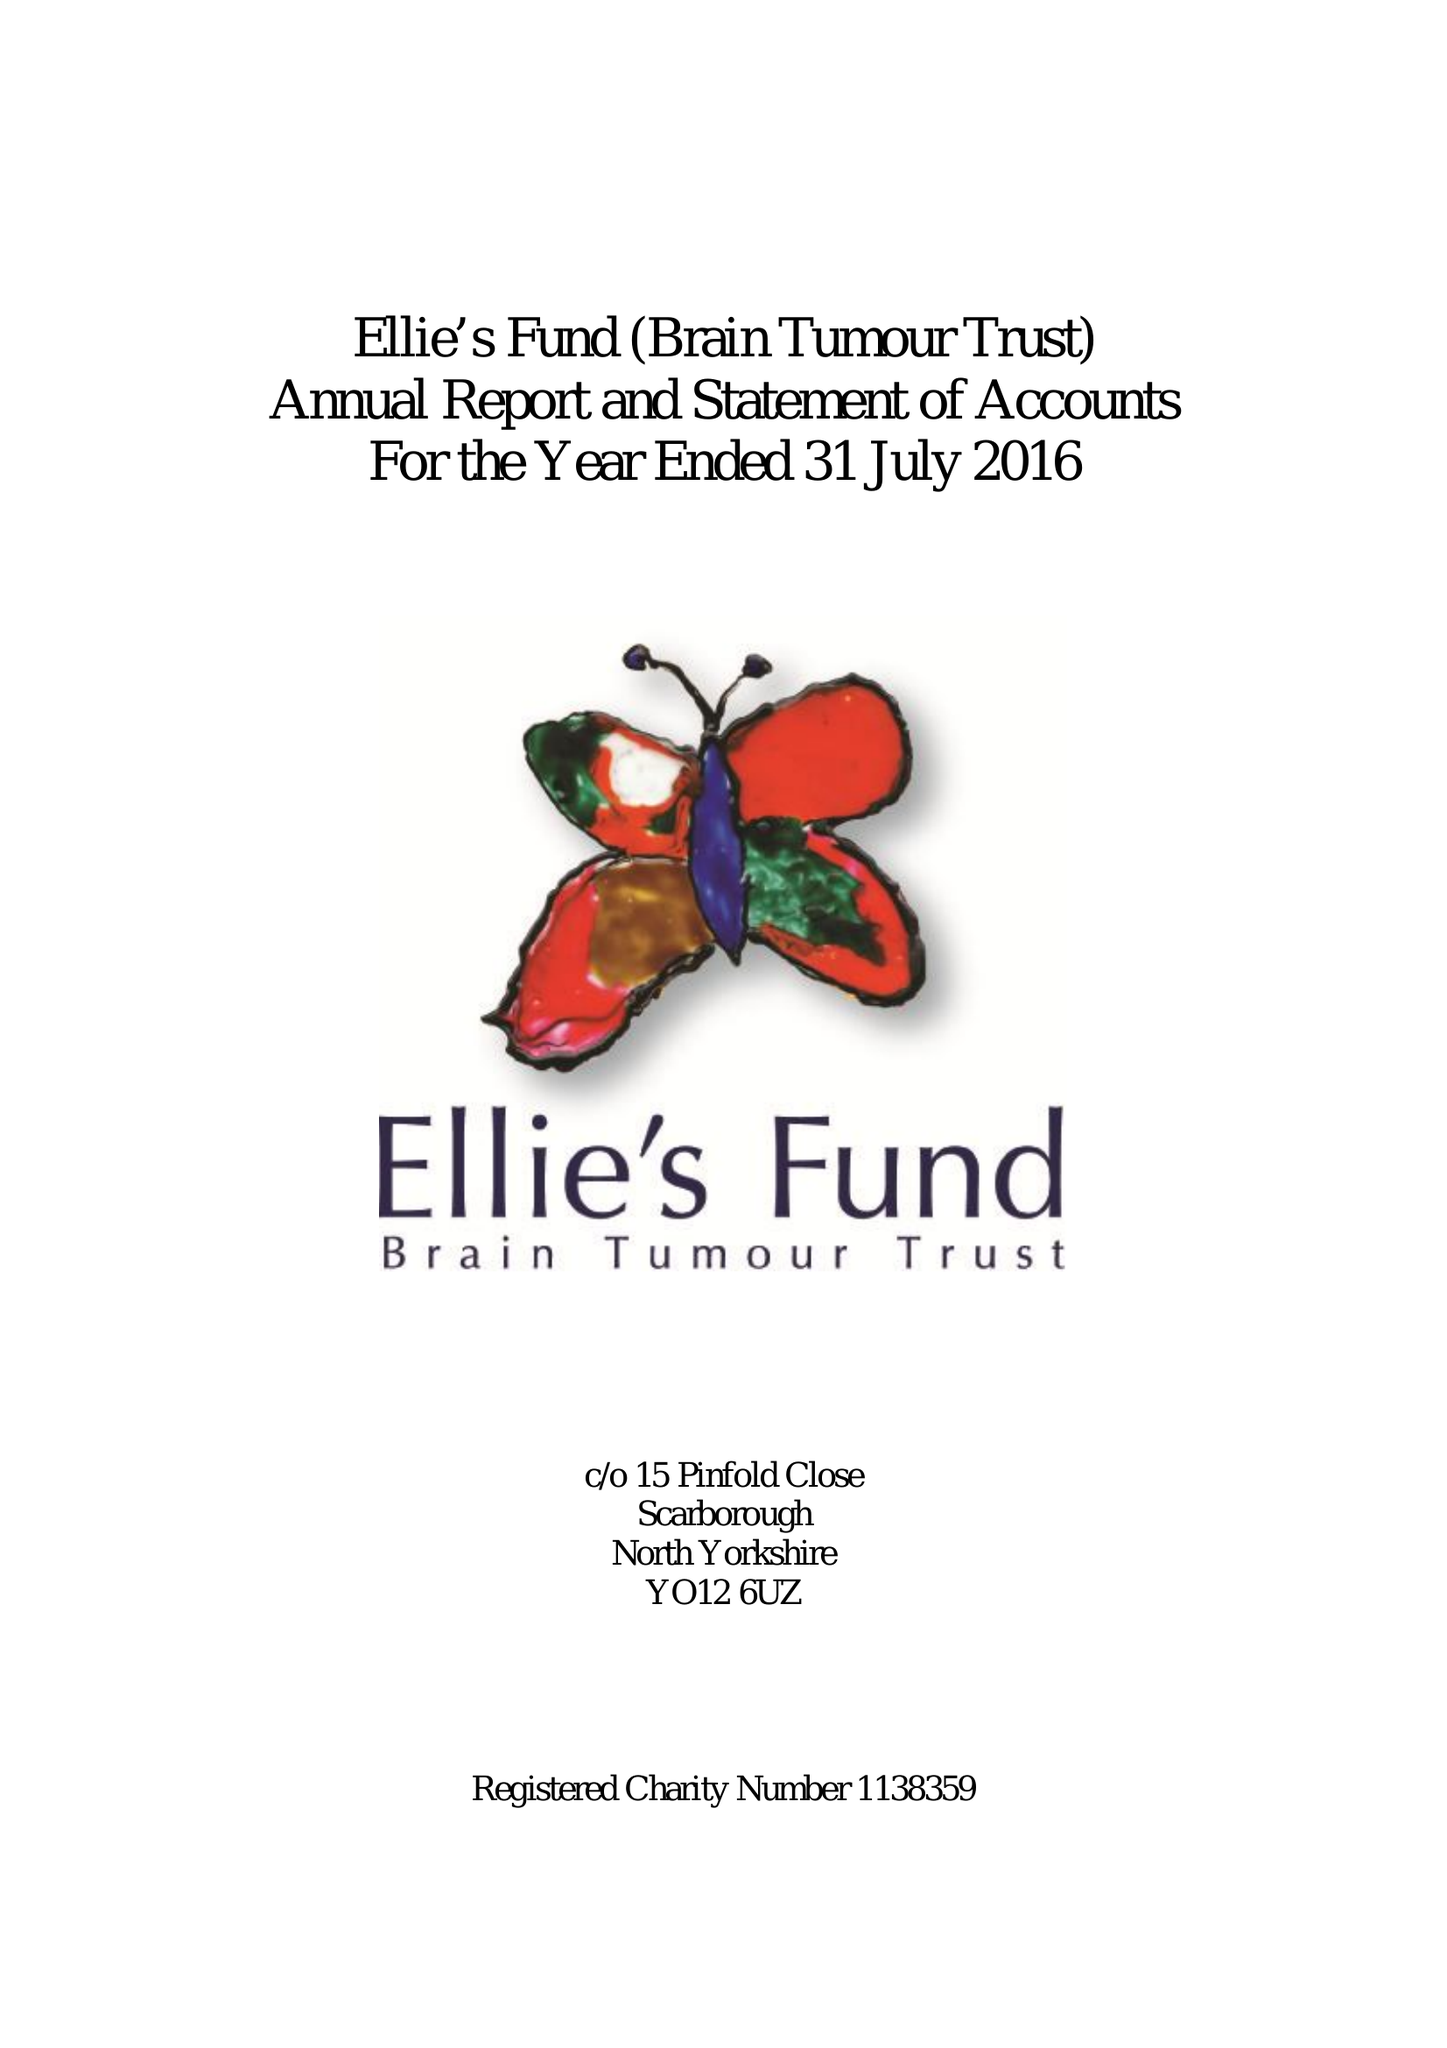What is the value for the charity_name?
Answer the question using a single word or phrase. Ellie's Fund (Brain Tumour Trust) 